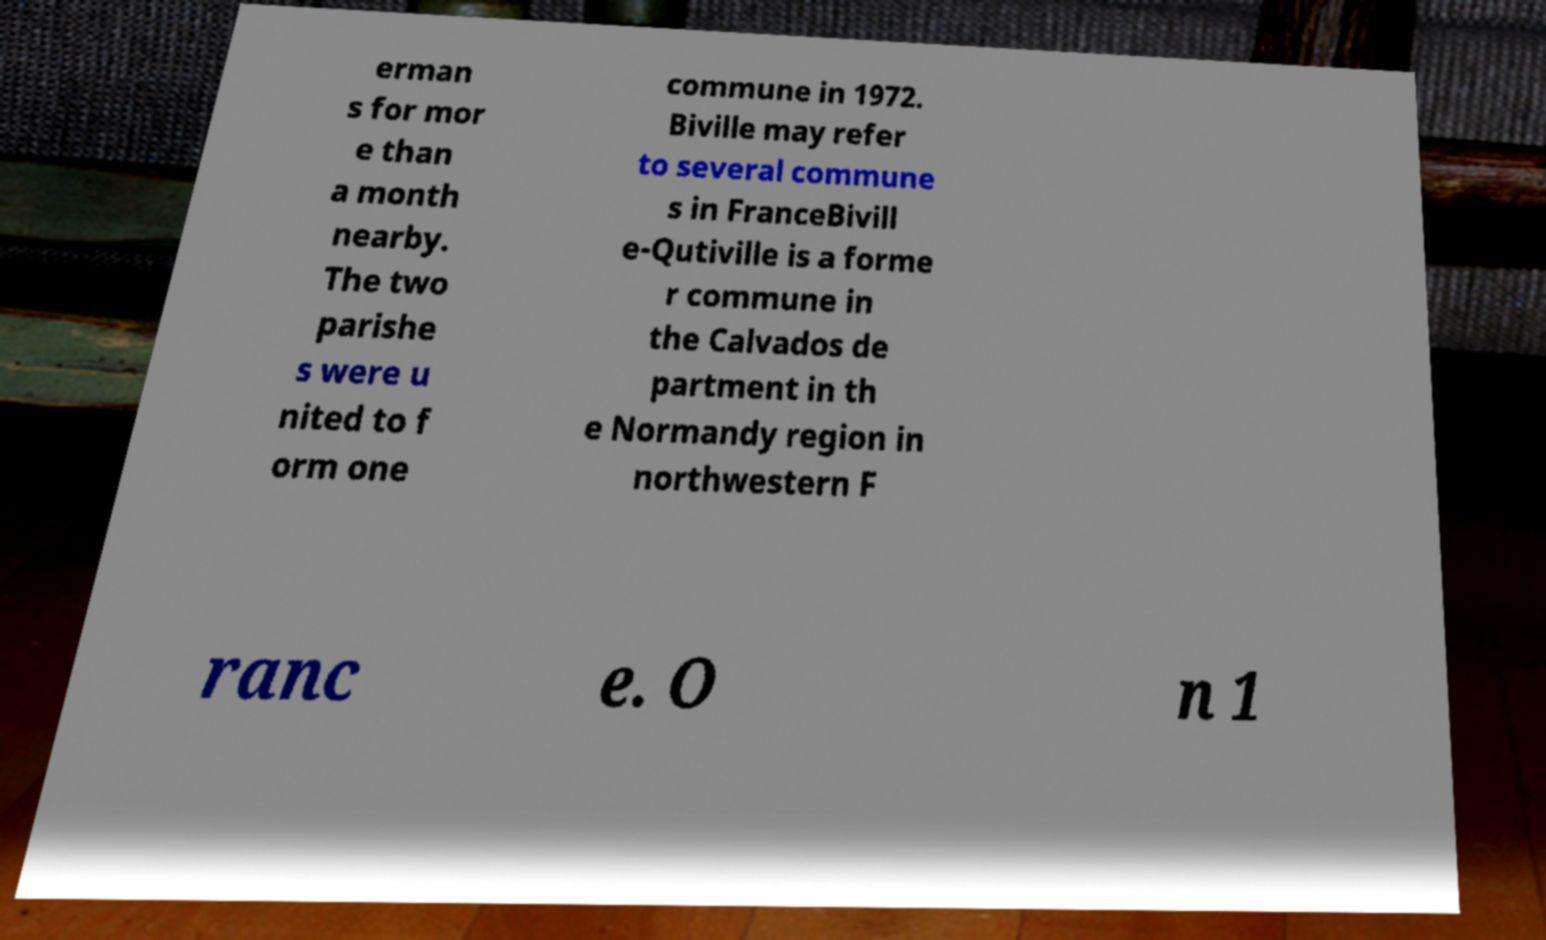Please identify and transcribe the text found in this image. erman s for mor e than a month nearby. The two parishe s were u nited to f orm one commune in 1972. Biville may refer to several commune s in FranceBivill e-Qutiville is a forme r commune in the Calvados de partment in th e Normandy region in northwestern F ranc e. O n 1 